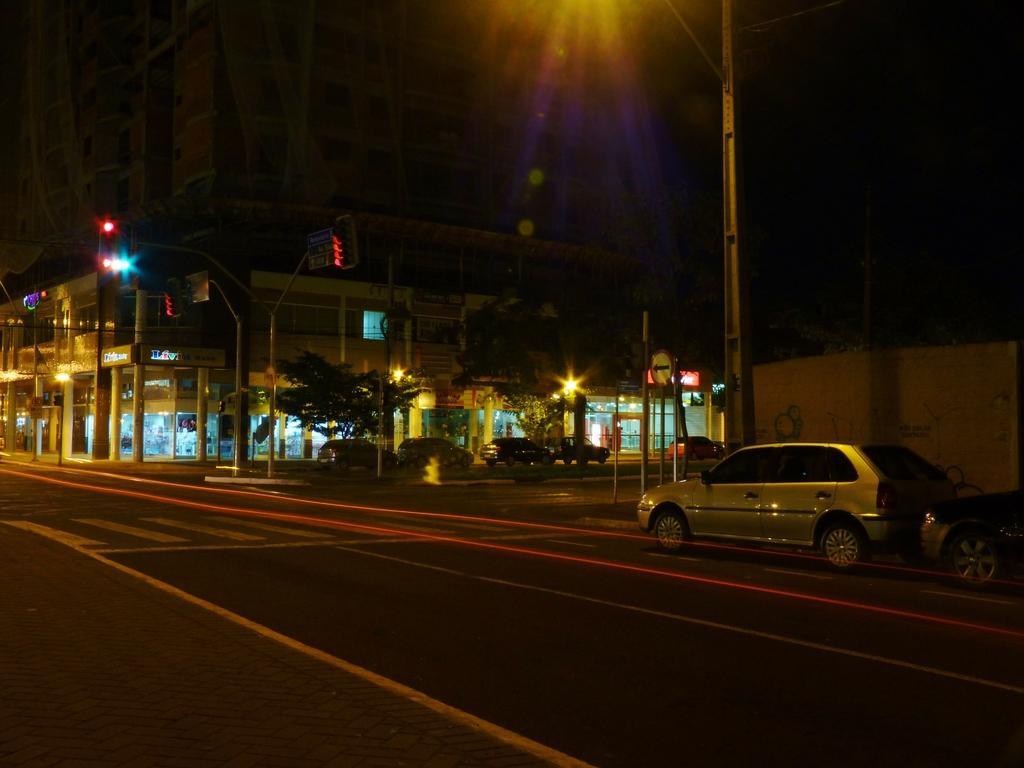Could you give a brief overview of what you see in this image? In the picture I can see the road and there are cars on the road. I can see the light poles and traffic signal pole on the road. There are trees on the side of the road. I can see the buildings on the side of the road. 